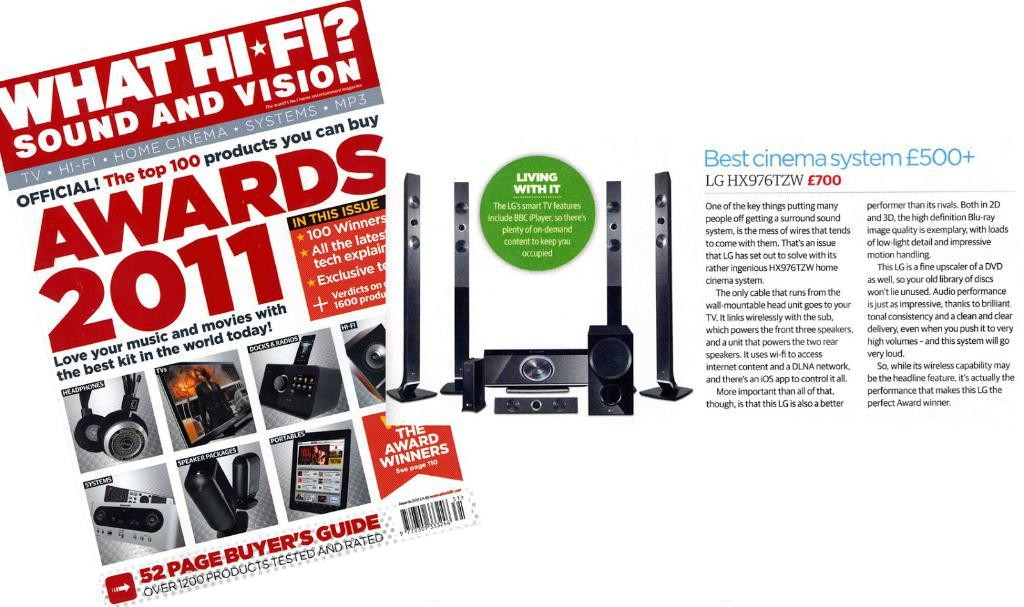<image>
Write a terse but informative summary of the picture. Magazine for "What Hi-Fi" advertising a set of speakers. 